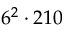Convert formula to latex. <formula><loc_0><loc_0><loc_500><loc_500>6 ^ { 2 } \cdot 2 1 0</formula> 